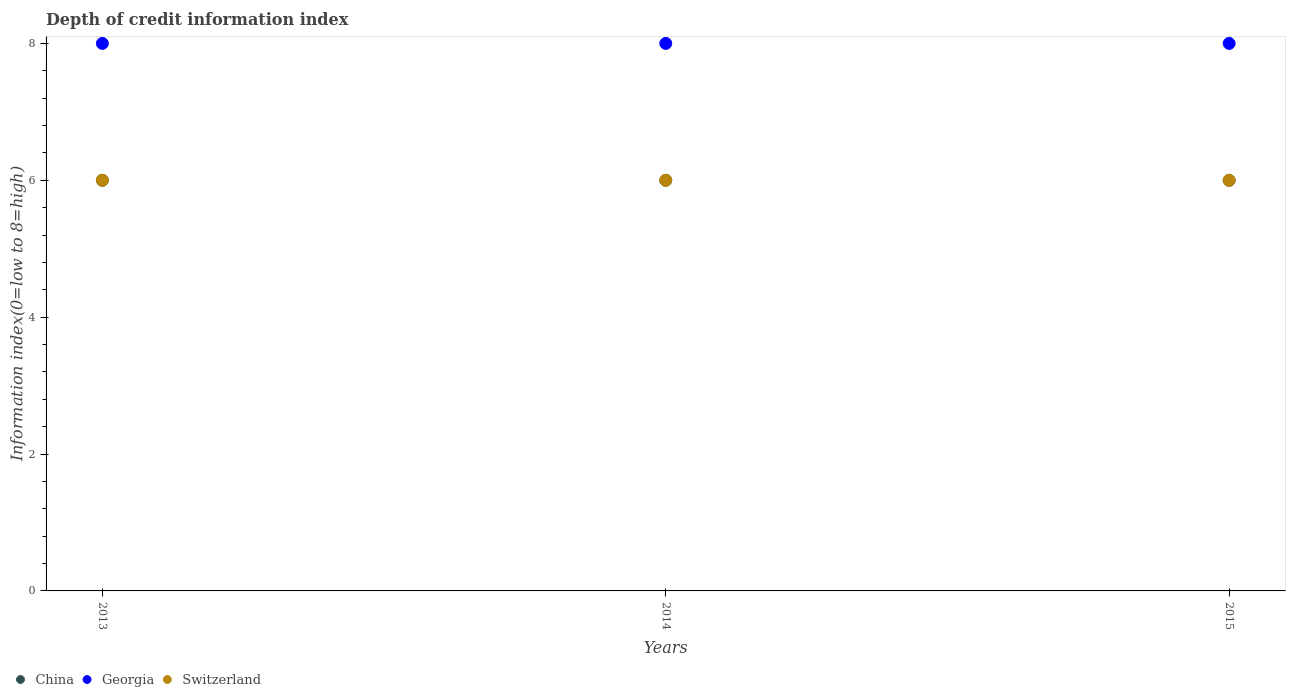How many different coloured dotlines are there?
Offer a terse response. 3. Across all years, what is the minimum information index in Switzerland?
Provide a succinct answer. 6. In which year was the information index in China maximum?
Your response must be concise. 2013. What is the total information index in Georgia in the graph?
Give a very brief answer. 24. What is the difference between the information index in Georgia in 2014 and that in 2015?
Provide a succinct answer. 0. What is the difference between the information index in Switzerland in 2015 and the information index in Georgia in 2014?
Your answer should be compact. -2. In how many years, is the information index in China greater than 4?
Offer a very short reply. 3. Does the information index in Georgia monotonically increase over the years?
Provide a succinct answer. No. Is the information index in Georgia strictly greater than the information index in China over the years?
Provide a short and direct response. Yes. What is the difference between two consecutive major ticks on the Y-axis?
Offer a very short reply. 2. Are the values on the major ticks of Y-axis written in scientific E-notation?
Give a very brief answer. No. Does the graph contain any zero values?
Your answer should be compact. No. Where does the legend appear in the graph?
Provide a short and direct response. Bottom left. How many legend labels are there?
Provide a short and direct response. 3. How are the legend labels stacked?
Your answer should be compact. Horizontal. What is the title of the graph?
Ensure brevity in your answer.  Depth of credit information index. Does "Grenada" appear as one of the legend labels in the graph?
Offer a very short reply. No. What is the label or title of the Y-axis?
Offer a terse response. Information index(0=low to 8=high). What is the Information index(0=low to 8=high) of China in 2013?
Provide a short and direct response. 6. What is the Information index(0=low to 8=high) in Georgia in 2013?
Ensure brevity in your answer.  8. What is the Information index(0=low to 8=high) of Switzerland in 2013?
Offer a very short reply. 6. What is the Information index(0=low to 8=high) of China in 2015?
Provide a succinct answer. 6. What is the Information index(0=low to 8=high) in Georgia in 2015?
Make the answer very short. 8. Across all years, what is the maximum Information index(0=low to 8=high) in Switzerland?
Offer a terse response. 6. Across all years, what is the minimum Information index(0=low to 8=high) of Switzerland?
Make the answer very short. 6. What is the total Information index(0=low to 8=high) of China in the graph?
Offer a very short reply. 18. What is the total Information index(0=low to 8=high) of Switzerland in the graph?
Make the answer very short. 18. What is the difference between the Information index(0=low to 8=high) in Switzerland in 2013 and that in 2014?
Offer a very short reply. 0. What is the difference between the Information index(0=low to 8=high) in China in 2013 and that in 2015?
Your answer should be compact. 0. What is the difference between the Information index(0=low to 8=high) of Georgia in 2013 and that in 2015?
Provide a succinct answer. 0. What is the difference between the Information index(0=low to 8=high) in Georgia in 2014 and that in 2015?
Your answer should be very brief. 0. What is the difference between the Information index(0=low to 8=high) of China in 2013 and the Information index(0=low to 8=high) of Georgia in 2014?
Provide a succinct answer. -2. What is the difference between the Information index(0=low to 8=high) of China in 2013 and the Information index(0=low to 8=high) of Switzerland in 2014?
Give a very brief answer. 0. What is the difference between the Information index(0=low to 8=high) of China in 2013 and the Information index(0=low to 8=high) of Georgia in 2015?
Your response must be concise. -2. What is the difference between the Information index(0=low to 8=high) in Georgia in 2014 and the Information index(0=low to 8=high) in Switzerland in 2015?
Your response must be concise. 2. What is the average Information index(0=low to 8=high) of China per year?
Provide a short and direct response. 6. What is the average Information index(0=low to 8=high) in Switzerland per year?
Provide a succinct answer. 6. In the year 2013, what is the difference between the Information index(0=low to 8=high) of China and Information index(0=low to 8=high) of Georgia?
Offer a terse response. -2. In the year 2014, what is the difference between the Information index(0=low to 8=high) in China and Information index(0=low to 8=high) in Georgia?
Provide a short and direct response. -2. In the year 2015, what is the difference between the Information index(0=low to 8=high) of China and Information index(0=low to 8=high) of Georgia?
Provide a succinct answer. -2. In the year 2015, what is the difference between the Information index(0=low to 8=high) of Georgia and Information index(0=low to 8=high) of Switzerland?
Offer a very short reply. 2. What is the ratio of the Information index(0=low to 8=high) in China in 2013 to that in 2014?
Your answer should be very brief. 1. What is the ratio of the Information index(0=low to 8=high) in Switzerland in 2013 to that in 2014?
Provide a succinct answer. 1. What is the ratio of the Information index(0=low to 8=high) in China in 2013 to that in 2015?
Keep it short and to the point. 1. What is the ratio of the Information index(0=low to 8=high) of Georgia in 2013 to that in 2015?
Your answer should be compact. 1. What is the ratio of the Information index(0=low to 8=high) in Georgia in 2014 to that in 2015?
Your answer should be compact. 1. What is the difference between the highest and the second highest Information index(0=low to 8=high) of Georgia?
Provide a succinct answer. 0. What is the difference between the highest and the second highest Information index(0=low to 8=high) in Switzerland?
Ensure brevity in your answer.  0. What is the difference between the highest and the lowest Information index(0=low to 8=high) of China?
Ensure brevity in your answer.  0. What is the difference between the highest and the lowest Information index(0=low to 8=high) in Switzerland?
Your answer should be compact. 0. 